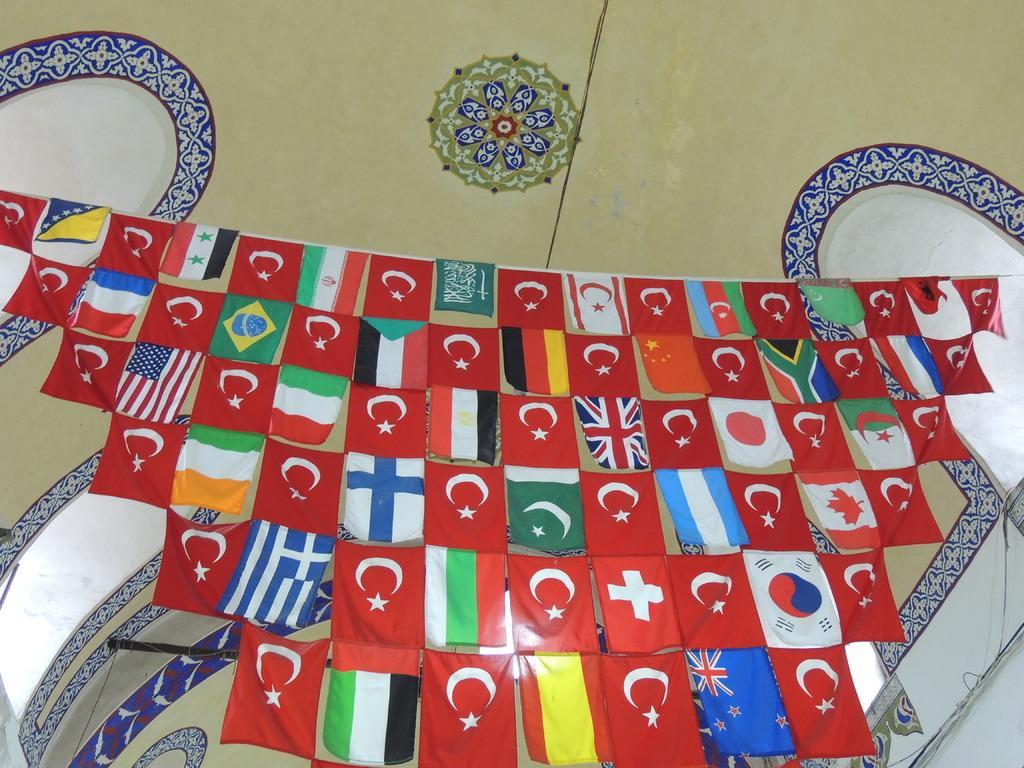Describe this image in one or two sentences. These are the kind of flags, which are hanging to the rope. I think this is the wall painting on the walls. 